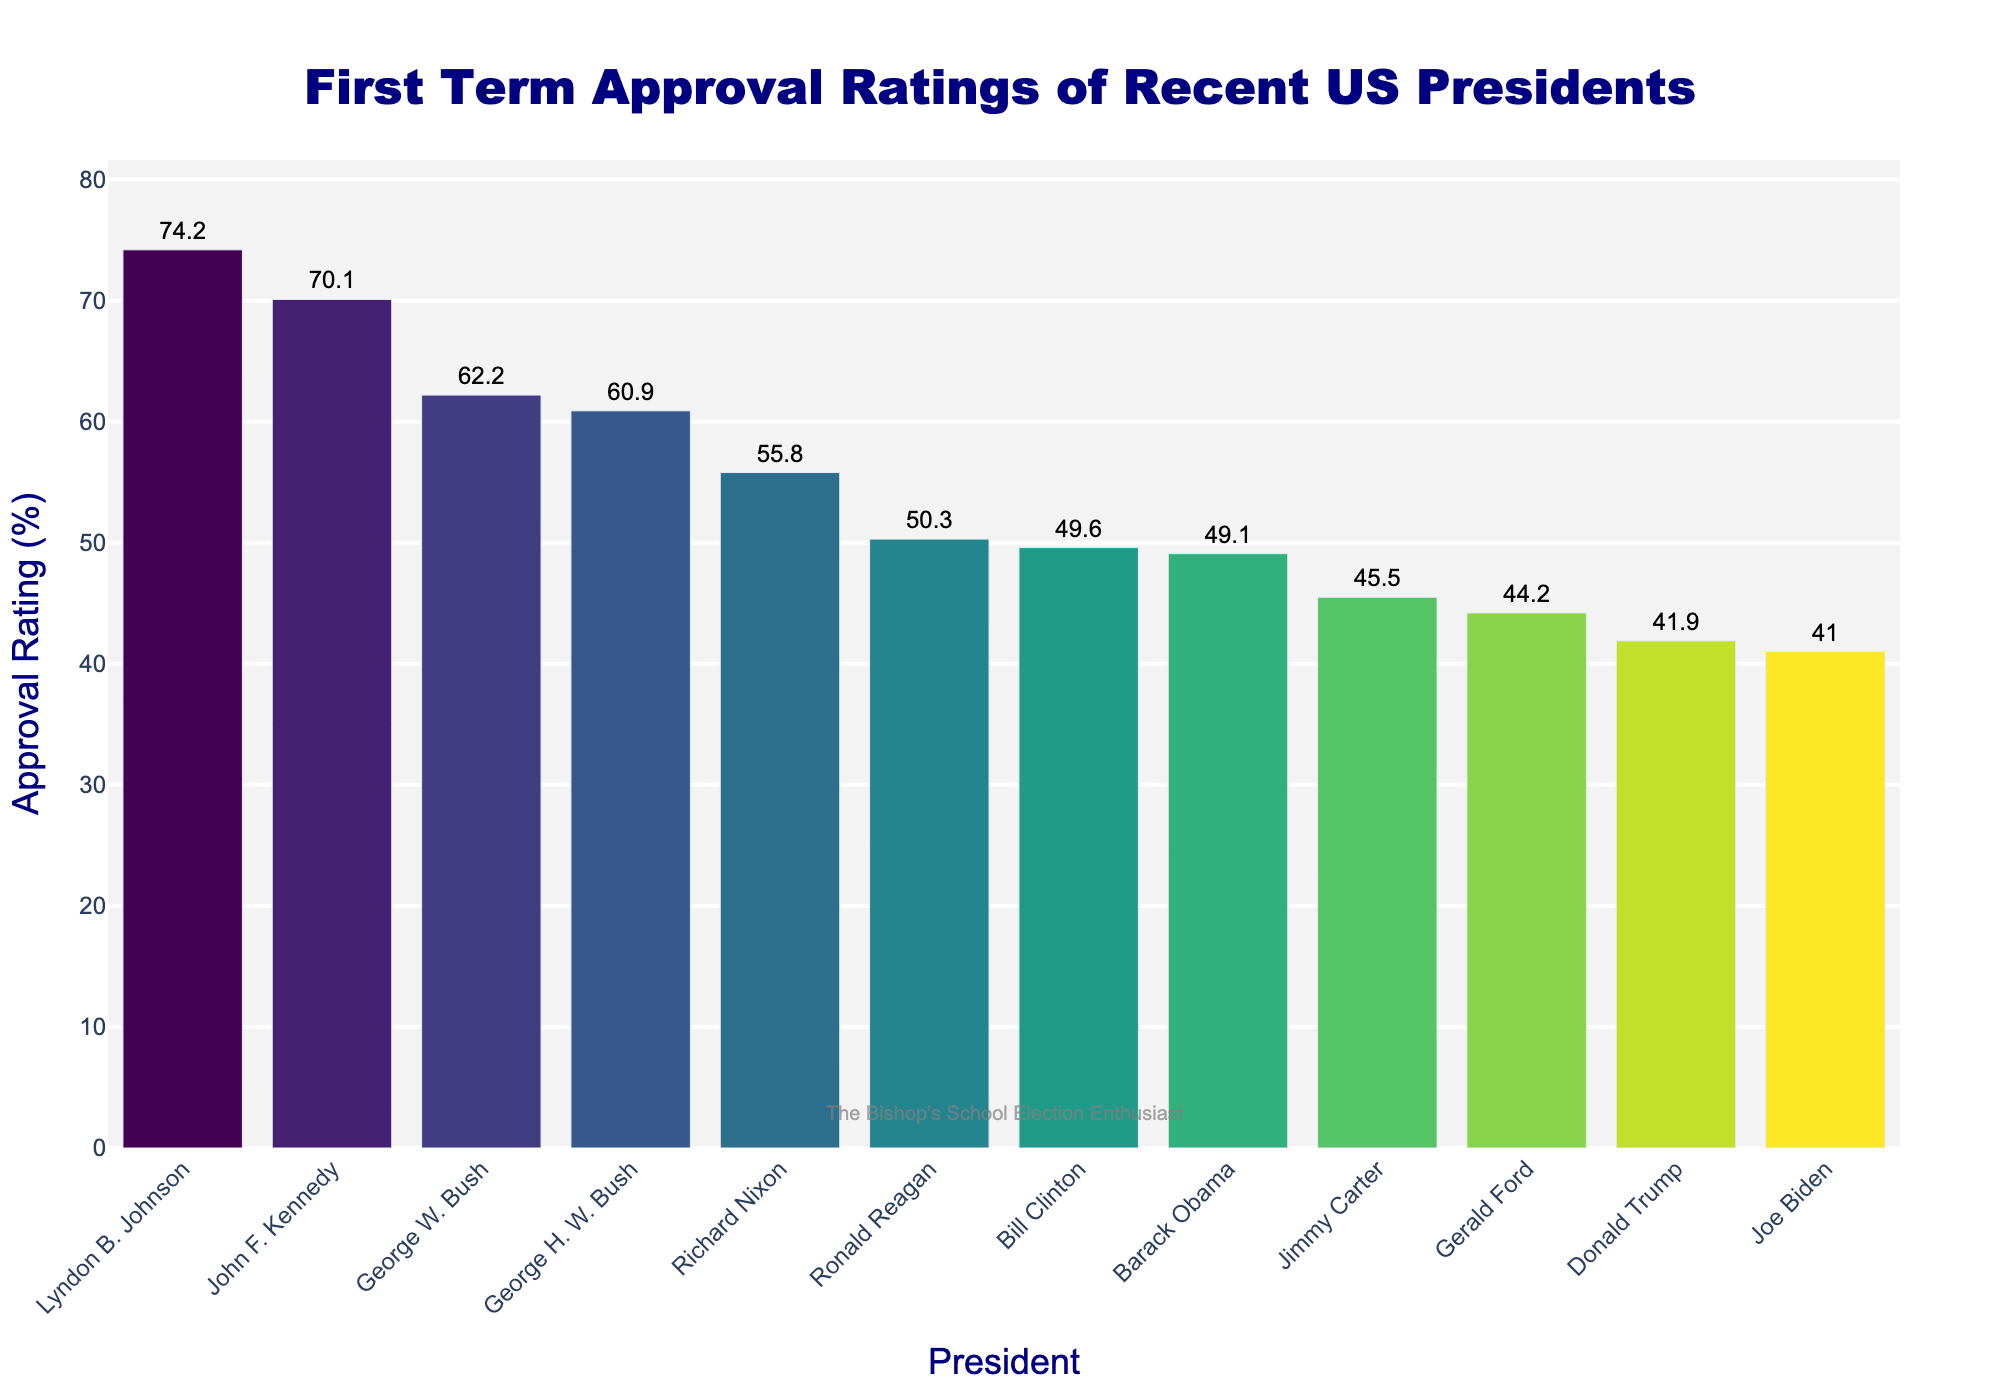Which president had the highest approval rating during their first term? The bar for Lyndon B. Johnson is the tallest among all presidents on the plot, indicating he had the highest approval rating.
Answer: Lyndon B. Johnson Which president had a lower approval rating during their first term, Richard Nixon or George H.W. Bush? The bar for George H.W. Bush is shorter than the bar for Richard Nixon, indicating that his approval rating was lower.
Answer: George H.W. Bush Who had a higher approval rating: Bill Clinton or Ronald Reagan? The bar for Ronald Reagan is slightly taller than the bar for Bill Clinton, indicating his approval rating was higher.
Answer: Ronald Reagan How much higher was Lyndon B. Johnson's approval rating compared to Joe Biden's? Lyndon B. Johnson's approval rating is 74.2%, and Joe Biden's approval rating is 41.0%. The difference is 74.2% - 41.0% = 33.2%.
Answer: 33.2% What was the average approval rating of the presidents listed in the figure? Sum all the approval ratings and divide by the number of presidents: (41.0 + 41.9 + 49.1 + 62.2 + 49.6 + 60.9 + 50.3 + 45.5 + 44.2 + 55.8 + 74.2 + 70.1)/12 ≈ 53.9%
Answer: 53.9% What is the color of the bar representing Jimmy Carter? The bar representing Jimmy Carter is shaded lighter compared to those with higher ratings, indicating a color from the lower end of the "Viridis" scale, trending towards a yellowish-green.
Answer: yellowish-green Is there a president whose approval rating is equal to or greater than 70%? The bars for Lyndon B. Johnson and John F. Kennedy both exceed the 70% mark.
Answer: Yes Which two presidents have approval ratings closest to each other? Bill Clinton (49.6%) and Barack Obama (49.1%) have approval ratings that are closest to each other, with only a 0.5 percentage points difference.
Answer: Bill Clinton and Barack Obama 